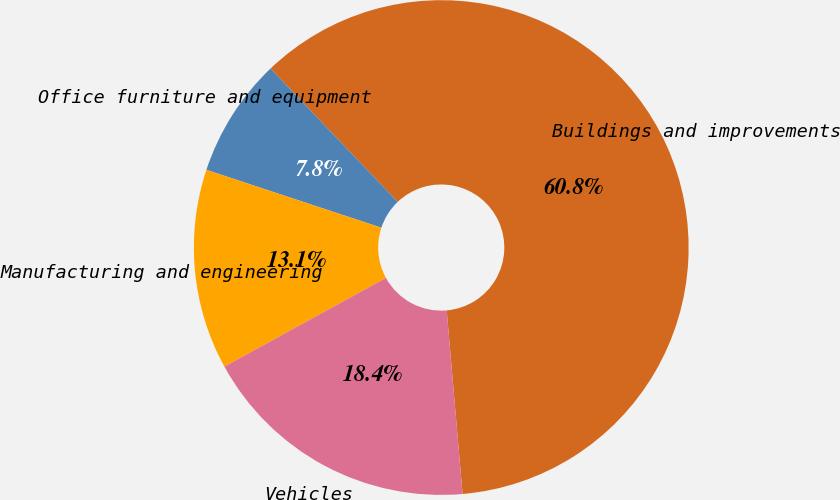Convert chart to OTSL. <chart><loc_0><loc_0><loc_500><loc_500><pie_chart><fcel>Buildings and improvements<fcel>Office furniture and equipment<fcel>Manufacturing and engineering<fcel>Vehicles<nl><fcel>60.75%<fcel>7.79%<fcel>13.08%<fcel>18.38%<nl></chart> 